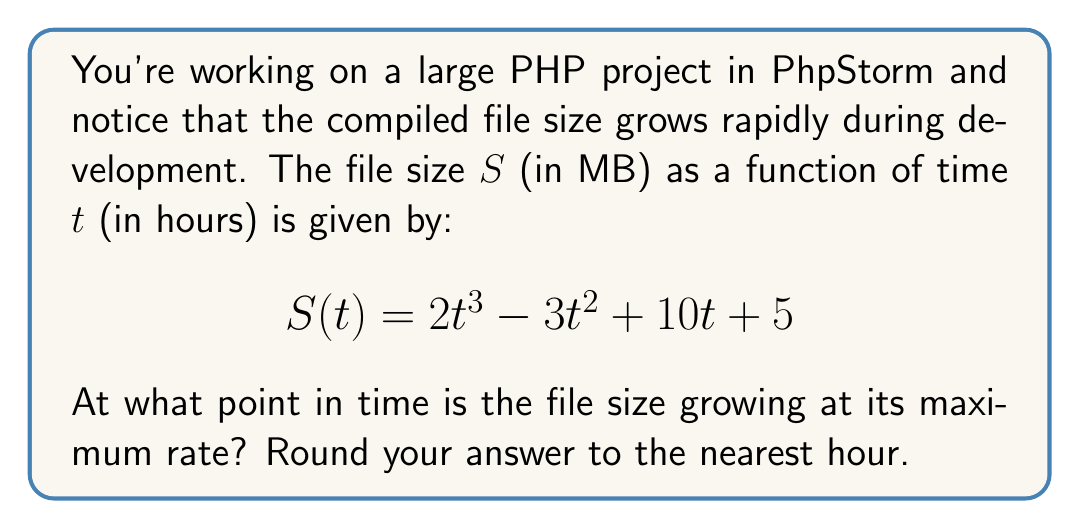Teach me how to tackle this problem. To find the point where the file size is growing at its maximum rate, we need to follow these steps:

1) The growth rate is represented by the derivative of $S(t)$. Let's call this $S'(t)$.

2) Calculate $S'(t)$:
   $$S'(t) = 6t^2 - 6t + 10$$

3) To find the maximum growth rate, we need to find where the second derivative $S''(t)$ equals zero:
   $$S''(t) = 12t - 6$$

4) Set $S''(t) = 0$ and solve for $t$:
   $$12t - 6 = 0$$
   $$12t = 6$$
   $$t = \frac{1}{2} = 0.5$$

5) To confirm this is a maximum (not a minimum), check that $S'''(t) < 0$:
   $$S'''(t) = 12$$
   Since this is positive, our critical point is actually a minimum of $S'(t)$, not a maximum.

6) This means the maximum growth rate occurs at one of the endpoints of our time domain. Since time can't be negative, we're looking at $t = 0$ or $t \to \infty$.

7) As $t \to \infty$, $S'(t) \to \infty$, so the growth rate is maximized as time approaches infinity.

8) However, since we need to round to the nearest hour, we can choose a sufficiently large value for $t$, such as $t = 1000$ hours.
Answer: 1000 hours 